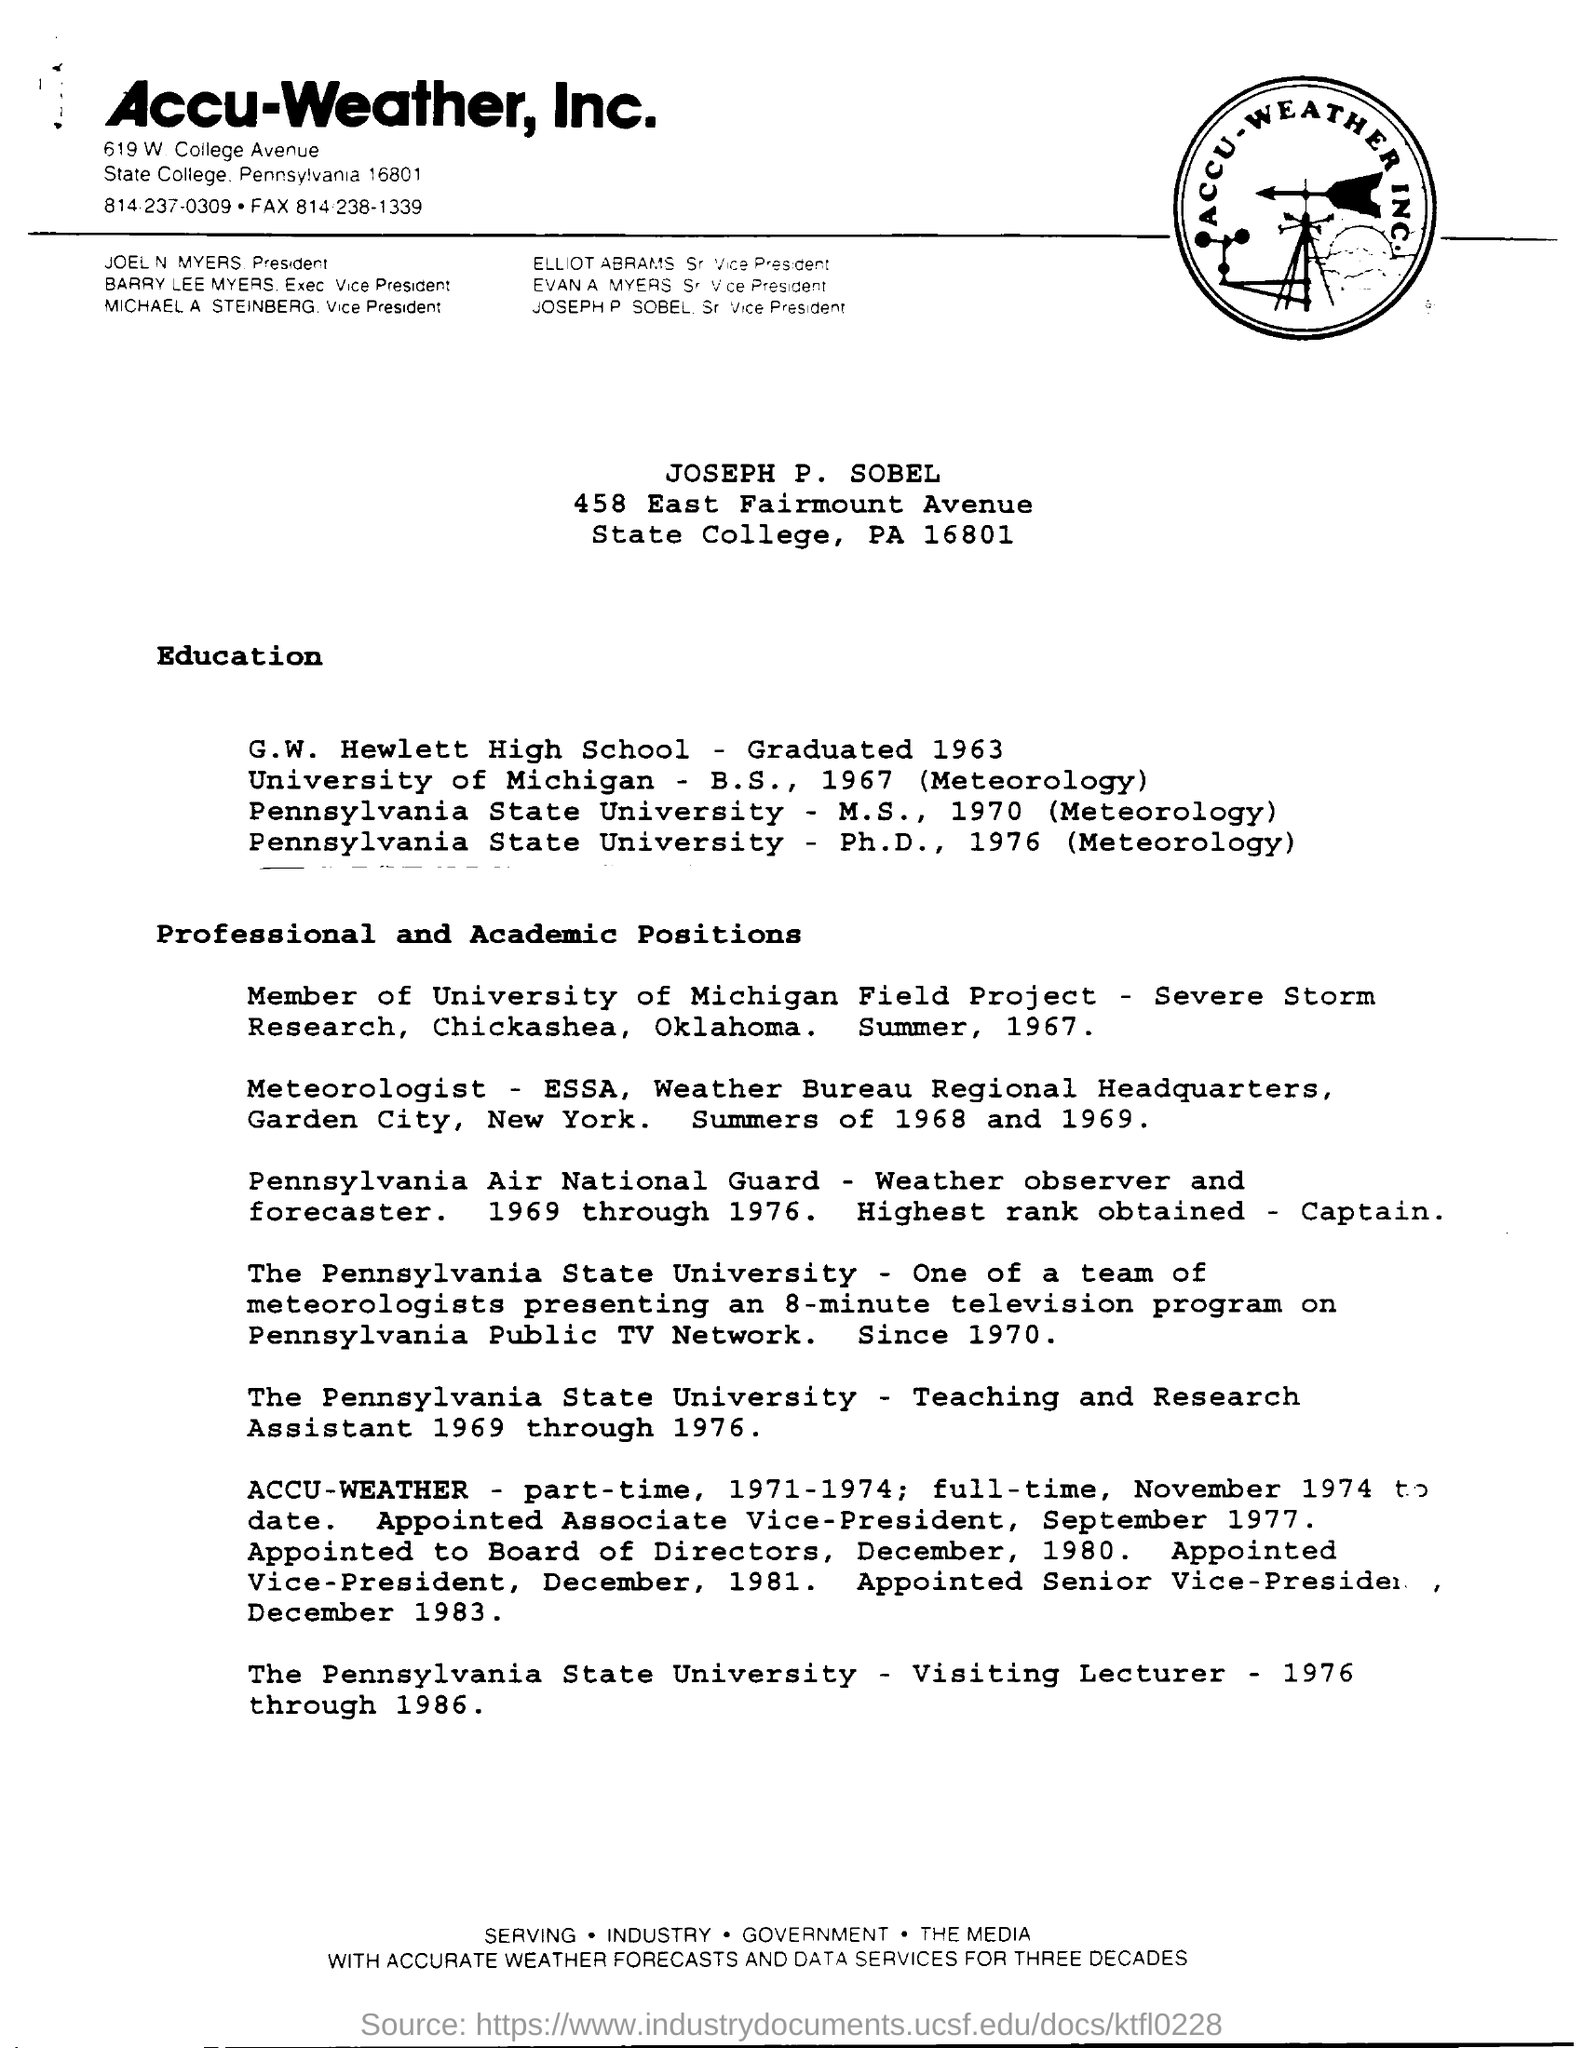Highlight a few significant elements in this photo. Joel N Myers is the President. The ACCU\_WEATHER INC firm is mentioned at the top of the page. Joseph graduated from G.W. Hewlett High School in the year 1963. 